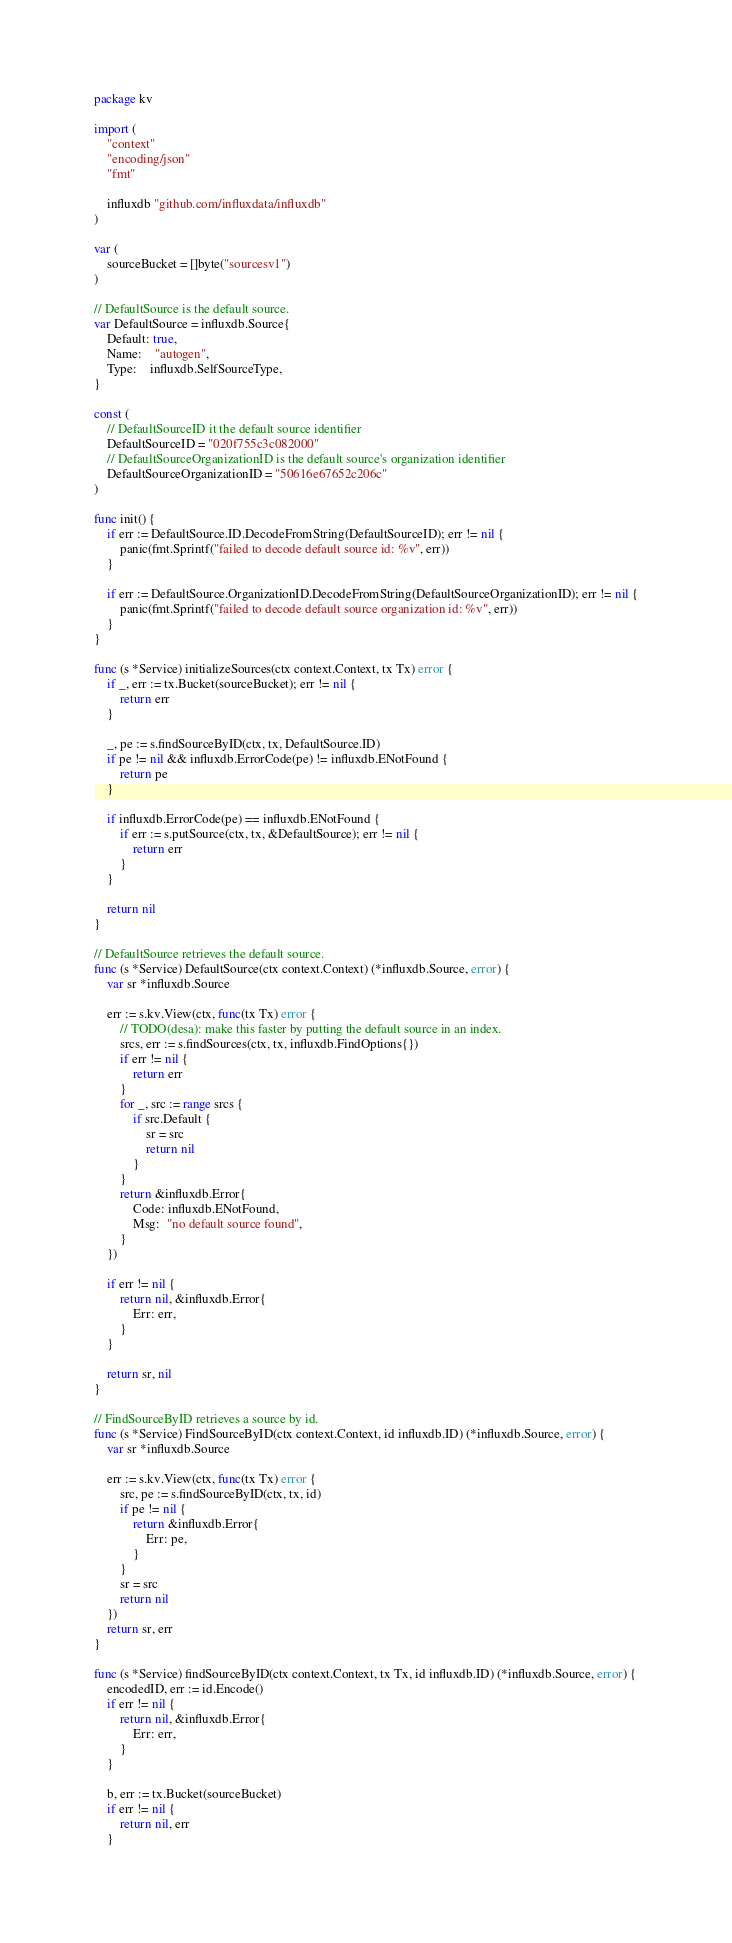<code> <loc_0><loc_0><loc_500><loc_500><_Go_>package kv

import (
	"context"
	"encoding/json"
	"fmt"

	influxdb "github.com/influxdata/influxdb"
)

var (
	sourceBucket = []byte("sourcesv1")
)

// DefaultSource is the default source.
var DefaultSource = influxdb.Source{
	Default: true,
	Name:    "autogen",
	Type:    influxdb.SelfSourceType,
}

const (
	// DefaultSourceID it the default source identifier
	DefaultSourceID = "020f755c3c082000"
	// DefaultSourceOrganizationID is the default source's organization identifier
	DefaultSourceOrganizationID = "50616e67652c206c"
)

func init() {
	if err := DefaultSource.ID.DecodeFromString(DefaultSourceID); err != nil {
		panic(fmt.Sprintf("failed to decode default source id: %v", err))
	}

	if err := DefaultSource.OrganizationID.DecodeFromString(DefaultSourceOrganizationID); err != nil {
		panic(fmt.Sprintf("failed to decode default source organization id: %v", err))
	}
}

func (s *Service) initializeSources(ctx context.Context, tx Tx) error {
	if _, err := tx.Bucket(sourceBucket); err != nil {
		return err
	}

	_, pe := s.findSourceByID(ctx, tx, DefaultSource.ID)
	if pe != nil && influxdb.ErrorCode(pe) != influxdb.ENotFound {
		return pe
	}

	if influxdb.ErrorCode(pe) == influxdb.ENotFound {
		if err := s.putSource(ctx, tx, &DefaultSource); err != nil {
			return err
		}
	}

	return nil
}

// DefaultSource retrieves the default source.
func (s *Service) DefaultSource(ctx context.Context) (*influxdb.Source, error) {
	var sr *influxdb.Source

	err := s.kv.View(ctx, func(tx Tx) error {
		// TODO(desa): make this faster by putting the default source in an index.
		srcs, err := s.findSources(ctx, tx, influxdb.FindOptions{})
		if err != nil {
			return err
		}
		for _, src := range srcs {
			if src.Default {
				sr = src
				return nil
			}
		}
		return &influxdb.Error{
			Code: influxdb.ENotFound,
			Msg:  "no default source found",
		}
	})

	if err != nil {
		return nil, &influxdb.Error{
			Err: err,
		}
	}

	return sr, nil
}

// FindSourceByID retrieves a source by id.
func (s *Service) FindSourceByID(ctx context.Context, id influxdb.ID) (*influxdb.Source, error) {
	var sr *influxdb.Source

	err := s.kv.View(ctx, func(tx Tx) error {
		src, pe := s.findSourceByID(ctx, tx, id)
		if pe != nil {
			return &influxdb.Error{
				Err: pe,
			}
		}
		sr = src
		return nil
	})
	return sr, err
}

func (s *Service) findSourceByID(ctx context.Context, tx Tx, id influxdb.ID) (*influxdb.Source, error) {
	encodedID, err := id.Encode()
	if err != nil {
		return nil, &influxdb.Error{
			Err: err,
		}
	}

	b, err := tx.Bucket(sourceBucket)
	if err != nil {
		return nil, err
	}
</code> 